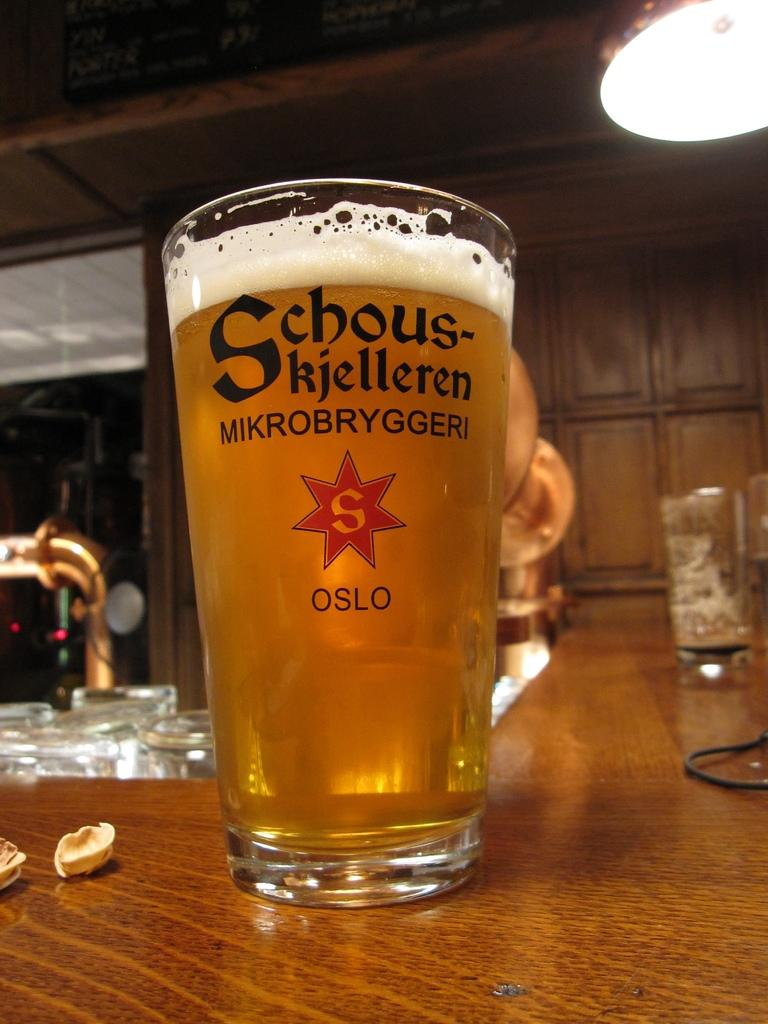Provide a one-sentence caption for the provided image. a tall glass of Schous-kjelleren MIKROBRYGGERI OSLO beer filled to the top. 